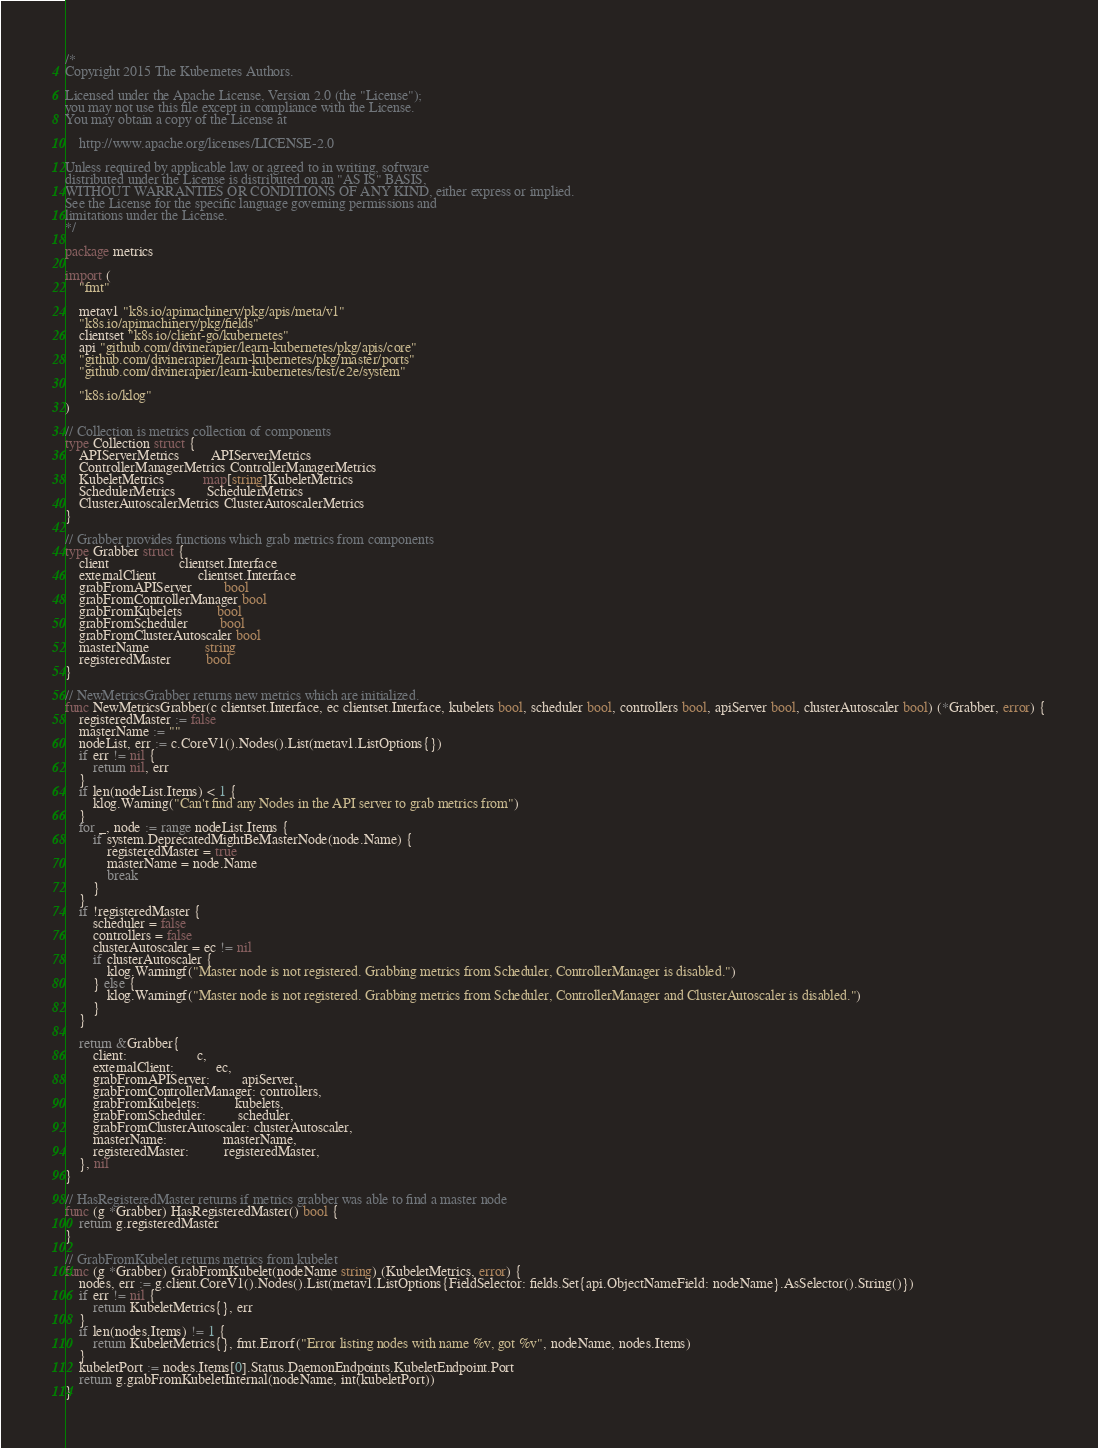Convert code to text. <code><loc_0><loc_0><loc_500><loc_500><_Go_>/*
Copyright 2015 The Kubernetes Authors.

Licensed under the Apache License, Version 2.0 (the "License");
you may not use this file except in compliance with the License.
You may obtain a copy of the License at

    http://www.apache.org/licenses/LICENSE-2.0

Unless required by applicable law or agreed to in writing, software
distributed under the License is distributed on an "AS IS" BASIS,
WITHOUT WARRANTIES OR CONDITIONS OF ANY KIND, either express or implied.
See the License for the specific language governing permissions and
limitations under the License.
*/

package metrics

import (
	"fmt"

	metav1 "k8s.io/apimachinery/pkg/apis/meta/v1"
	"k8s.io/apimachinery/pkg/fields"
	clientset "k8s.io/client-go/kubernetes"
	api "github.com/divinerapier/learn-kubernetes/pkg/apis/core"
	"github.com/divinerapier/learn-kubernetes/pkg/master/ports"
	"github.com/divinerapier/learn-kubernetes/test/e2e/system"

	"k8s.io/klog"
)

// Collection is metrics collection of components
type Collection struct {
	APIServerMetrics         APIServerMetrics
	ControllerManagerMetrics ControllerManagerMetrics
	KubeletMetrics           map[string]KubeletMetrics
	SchedulerMetrics         SchedulerMetrics
	ClusterAutoscalerMetrics ClusterAutoscalerMetrics
}

// Grabber provides functions which grab metrics from components
type Grabber struct {
	client                    clientset.Interface
	externalClient            clientset.Interface
	grabFromAPIServer         bool
	grabFromControllerManager bool
	grabFromKubelets          bool
	grabFromScheduler         bool
	grabFromClusterAutoscaler bool
	masterName                string
	registeredMaster          bool
}

// NewMetricsGrabber returns new metrics which are initialized.
func NewMetricsGrabber(c clientset.Interface, ec clientset.Interface, kubelets bool, scheduler bool, controllers bool, apiServer bool, clusterAutoscaler bool) (*Grabber, error) {
	registeredMaster := false
	masterName := ""
	nodeList, err := c.CoreV1().Nodes().List(metav1.ListOptions{})
	if err != nil {
		return nil, err
	}
	if len(nodeList.Items) < 1 {
		klog.Warning("Can't find any Nodes in the API server to grab metrics from")
	}
	for _, node := range nodeList.Items {
		if system.DeprecatedMightBeMasterNode(node.Name) {
			registeredMaster = true
			masterName = node.Name
			break
		}
	}
	if !registeredMaster {
		scheduler = false
		controllers = false
		clusterAutoscaler = ec != nil
		if clusterAutoscaler {
			klog.Warningf("Master node is not registered. Grabbing metrics from Scheduler, ControllerManager is disabled.")
		} else {
			klog.Warningf("Master node is not registered. Grabbing metrics from Scheduler, ControllerManager and ClusterAutoscaler is disabled.")
		}
	}

	return &Grabber{
		client:                    c,
		externalClient:            ec,
		grabFromAPIServer:         apiServer,
		grabFromControllerManager: controllers,
		grabFromKubelets:          kubelets,
		grabFromScheduler:         scheduler,
		grabFromClusterAutoscaler: clusterAutoscaler,
		masterName:                masterName,
		registeredMaster:          registeredMaster,
	}, nil
}

// HasRegisteredMaster returns if metrics grabber was able to find a master node
func (g *Grabber) HasRegisteredMaster() bool {
	return g.registeredMaster
}

// GrabFromKubelet returns metrics from kubelet
func (g *Grabber) GrabFromKubelet(nodeName string) (KubeletMetrics, error) {
	nodes, err := g.client.CoreV1().Nodes().List(metav1.ListOptions{FieldSelector: fields.Set{api.ObjectNameField: nodeName}.AsSelector().String()})
	if err != nil {
		return KubeletMetrics{}, err
	}
	if len(nodes.Items) != 1 {
		return KubeletMetrics{}, fmt.Errorf("Error listing nodes with name %v, got %v", nodeName, nodes.Items)
	}
	kubeletPort := nodes.Items[0].Status.DaemonEndpoints.KubeletEndpoint.Port
	return g.grabFromKubeletInternal(nodeName, int(kubeletPort))
}
</code> 